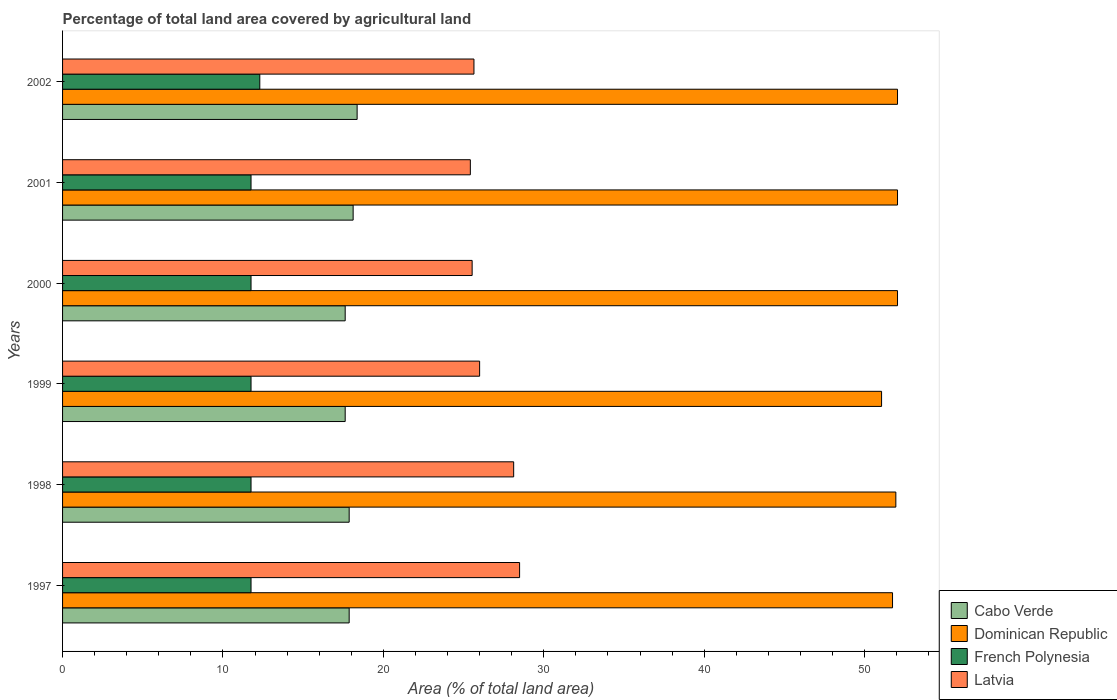Are the number of bars per tick equal to the number of legend labels?
Your response must be concise. Yes. How many bars are there on the 5th tick from the top?
Give a very brief answer. 4. What is the label of the 1st group of bars from the top?
Provide a short and direct response. 2002. What is the percentage of agricultural land in Latvia in 2001?
Offer a terse response. 25.42. Across all years, what is the maximum percentage of agricultural land in Cabo Verde?
Offer a very short reply. 18.36. Across all years, what is the minimum percentage of agricultural land in French Polynesia?
Make the answer very short. 11.75. In which year was the percentage of agricultural land in French Polynesia maximum?
Offer a very short reply. 2002. What is the total percentage of agricultural land in French Polynesia in the graph?
Make the answer very short. 71.04. What is the difference between the percentage of agricultural land in Dominican Republic in 1997 and that in 1999?
Ensure brevity in your answer.  0.68. What is the difference between the percentage of agricultural land in Latvia in 1997 and the percentage of agricultural land in Cabo Verde in 2001?
Your answer should be compact. 10.38. What is the average percentage of agricultural land in Cabo Verde per year?
Your answer should be compact. 17.91. In the year 1997, what is the difference between the percentage of agricultural land in Cabo Verde and percentage of agricultural land in French Polynesia?
Offer a very short reply. 6.12. What is the ratio of the percentage of agricultural land in Dominican Republic in 1998 to that in 2000?
Offer a terse response. 1. What is the difference between the highest and the second highest percentage of agricultural land in Latvia?
Give a very brief answer. 0.37. What is the difference between the highest and the lowest percentage of agricultural land in Latvia?
Keep it short and to the point. 3.07. In how many years, is the percentage of agricultural land in Cabo Verde greater than the average percentage of agricultural land in Cabo Verde taken over all years?
Make the answer very short. 2. Is it the case that in every year, the sum of the percentage of agricultural land in Cabo Verde and percentage of agricultural land in French Polynesia is greater than the sum of percentage of agricultural land in Latvia and percentage of agricultural land in Dominican Republic?
Ensure brevity in your answer.  Yes. What does the 4th bar from the top in 1997 represents?
Offer a terse response. Cabo Verde. What does the 1st bar from the bottom in 1998 represents?
Your answer should be very brief. Cabo Verde. Is it the case that in every year, the sum of the percentage of agricultural land in Latvia and percentage of agricultural land in Cabo Verde is greater than the percentage of agricultural land in French Polynesia?
Your answer should be compact. Yes. Are all the bars in the graph horizontal?
Give a very brief answer. Yes. How many years are there in the graph?
Make the answer very short. 6. What is the difference between two consecutive major ticks on the X-axis?
Offer a terse response. 10. Are the values on the major ticks of X-axis written in scientific E-notation?
Provide a succinct answer. No. Does the graph contain grids?
Your response must be concise. No. How are the legend labels stacked?
Ensure brevity in your answer.  Vertical. What is the title of the graph?
Offer a terse response. Percentage of total land area covered by agricultural land. What is the label or title of the X-axis?
Your response must be concise. Area (% of total land area). What is the label or title of the Y-axis?
Make the answer very short. Years. What is the Area (% of total land area) in Cabo Verde in 1997?
Offer a terse response. 17.87. What is the Area (% of total land area) of Dominican Republic in 1997?
Your response must be concise. 51.74. What is the Area (% of total land area) of French Polynesia in 1997?
Keep it short and to the point. 11.75. What is the Area (% of total land area) in Latvia in 1997?
Offer a very short reply. 28.49. What is the Area (% of total land area) of Cabo Verde in 1998?
Your answer should be very brief. 17.87. What is the Area (% of total land area) in Dominican Republic in 1998?
Your answer should be very brief. 51.95. What is the Area (% of total land area) of French Polynesia in 1998?
Provide a succinct answer. 11.75. What is the Area (% of total land area) in Latvia in 1998?
Your answer should be compact. 28.12. What is the Area (% of total land area) in Cabo Verde in 1999?
Your answer should be very brief. 17.62. What is the Area (% of total land area) of Dominican Republic in 1999?
Ensure brevity in your answer.  51.06. What is the Area (% of total land area) in French Polynesia in 1999?
Your answer should be very brief. 11.75. What is the Area (% of total land area) in Latvia in 1999?
Offer a very short reply. 26. What is the Area (% of total land area) in Cabo Verde in 2000?
Offer a terse response. 17.62. What is the Area (% of total land area) of Dominican Republic in 2000?
Provide a short and direct response. 52.05. What is the Area (% of total land area) in French Polynesia in 2000?
Ensure brevity in your answer.  11.75. What is the Area (% of total land area) of Latvia in 2000?
Provide a short and direct response. 25.53. What is the Area (% of total land area) of Cabo Verde in 2001?
Your answer should be very brief. 18.11. What is the Area (% of total land area) in Dominican Republic in 2001?
Your answer should be compact. 52.05. What is the Area (% of total land area) in French Polynesia in 2001?
Your response must be concise. 11.75. What is the Area (% of total land area) of Latvia in 2001?
Keep it short and to the point. 25.42. What is the Area (% of total land area) of Cabo Verde in 2002?
Ensure brevity in your answer.  18.36. What is the Area (% of total land area) of Dominican Republic in 2002?
Your response must be concise. 52.05. What is the Area (% of total land area) of French Polynesia in 2002?
Your response must be concise. 12.3. What is the Area (% of total land area) of Latvia in 2002?
Provide a short and direct response. 25.64. Across all years, what is the maximum Area (% of total land area) of Cabo Verde?
Provide a succinct answer. 18.36. Across all years, what is the maximum Area (% of total land area) of Dominican Republic?
Provide a succinct answer. 52.05. Across all years, what is the maximum Area (% of total land area) of French Polynesia?
Keep it short and to the point. 12.3. Across all years, what is the maximum Area (% of total land area) in Latvia?
Keep it short and to the point. 28.49. Across all years, what is the minimum Area (% of total land area) in Cabo Verde?
Your response must be concise. 17.62. Across all years, what is the minimum Area (% of total land area) of Dominican Republic?
Provide a short and direct response. 51.06. Across all years, what is the minimum Area (% of total land area) in French Polynesia?
Give a very brief answer. 11.75. Across all years, what is the minimum Area (% of total land area) of Latvia?
Ensure brevity in your answer.  25.42. What is the total Area (% of total land area) in Cabo Verde in the graph?
Offer a very short reply. 107.44. What is the total Area (% of total land area) of Dominican Republic in the graph?
Offer a terse response. 310.89. What is the total Area (% of total land area) in French Polynesia in the graph?
Give a very brief answer. 71.04. What is the total Area (% of total land area) of Latvia in the graph?
Make the answer very short. 159.21. What is the difference between the Area (% of total land area) of Dominican Republic in 1997 and that in 1998?
Keep it short and to the point. -0.21. What is the difference between the Area (% of total land area) of French Polynesia in 1997 and that in 1998?
Give a very brief answer. 0. What is the difference between the Area (% of total land area) of Latvia in 1997 and that in 1998?
Your answer should be very brief. 0.37. What is the difference between the Area (% of total land area) of Cabo Verde in 1997 and that in 1999?
Ensure brevity in your answer.  0.25. What is the difference between the Area (% of total land area) of Dominican Republic in 1997 and that in 1999?
Provide a short and direct response. 0.68. What is the difference between the Area (% of total land area) of French Polynesia in 1997 and that in 1999?
Your response must be concise. 0. What is the difference between the Area (% of total land area) in Latvia in 1997 and that in 1999?
Your answer should be very brief. 2.49. What is the difference between the Area (% of total land area) of Cabo Verde in 1997 and that in 2000?
Provide a succinct answer. 0.25. What is the difference between the Area (% of total land area) of Dominican Republic in 1997 and that in 2000?
Ensure brevity in your answer.  -0.31. What is the difference between the Area (% of total land area) of French Polynesia in 1997 and that in 2000?
Your response must be concise. 0. What is the difference between the Area (% of total land area) of Latvia in 1997 and that in 2000?
Make the answer very short. 2.96. What is the difference between the Area (% of total land area) of Cabo Verde in 1997 and that in 2001?
Offer a terse response. -0.25. What is the difference between the Area (% of total land area) of Dominican Republic in 1997 and that in 2001?
Your answer should be very brief. -0.31. What is the difference between the Area (% of total land area) in Latvia in 1997 and that in 2001?
Keep it short and to the point. 3.07. What is the difference between the Area (% of total land area) of Cabo Verde in 1997 and that in 2002?
Provide a succinct answer. -0.5. What is the difference between the Area (% of total land area) of Dominican Republic in 1997 and that in 2002?
Make the answer very short. -0.31. What is the difference between the Area (% of total land area) in French Polynesia in 1997 and that in 2002?
Make the answer very short. -0.55. What is the difference between the Area (% of total land area) of Latvia in 1997 and that in 2002?
Provide a short and direct response. 2.85. What is the difference between the Area (% of total land area) in Cabo Verde in 1998 and that in 1999?
Provide a short and direct response. 0.25. What is the difference between the Area (% of total land area) of Dominican Republic in 1998 and that in 1999?
Your answer should be very brief. 0.89. What is the difference between the Area (% of total land area) of Latvia in 1998 and that in 1999?
Keep it short and to the point. 2.12. What is the difference between the Area (% of total land area) of Cabo Verde in 1998 and that in 2000?
Provide a succinct answer. 0.25. What is the difference between the Area (% of total land area) in Dominican Republic in 1998 and that in 2000?
Ensure brevity in your answer.  -0.1. What is the difference between the Area (% of total land area) of Latvia in 1998 and that in 2000?
Offer a terse response. 2.59. What is the difference between the Area (% of total land area) of Cabo Verde in 1998 and that in 2001?
Provide a succinct answer. -0.25. What is the difference between the Area (% of total land area) in Dominican Republic in 1998 and that in 2001?
Make the answer very short. -0.1. What is the difference between the Area (% of total land area) in Latvia in 1998 and that in 2001?
Keep it short and to the point. 2.7. What is the difference between the Area (% of total land area) of Cabo Verde in 1998 and that in 2002?
Give a very brief answer. -0.5. What is the difference between the Area (% of total land area) in Dominican Republic in 1998 and that in 2002?
Make the answer very short. -0.1. What is the difference between the Area (% of total land area) of French Polynesia in 1998 and that in 2002?
Offer a terse response. -0.55. What is the difference between the Area (% of total land area) of Latvia in 1998 and that in 2002?
Provide a succinct answer. 2.48. What is the difference between the Area (% of total land area) of Cabo Verde in 1999 and that in 2000?
Provide a short and direct response. 0. What is the difference between the Area (% of total land area) in Dominican Republic in 1999 and that in 2000?
Your answer should be compact. -0.99. What is the difference between the Area (% of total land area) of Latvia in 1999 and that in 2000?
Give a very brief answer. 0.47. What is the difference between the Area (% of total land area) in Cabo Verde in 1999 and that in 2001?
Keep it short and to the point. -0.5. What is the difference between the Area (% of total land area) in Dominican Republic in 1999 and that in 2001?
Ensure brevity in your answer.  -0.99. What is the difference between the Area (% of total land area) in French Polynesia in 1999 and that in 2001?
Make the answer very short. 0. What is the difference between the Area (% of total land area) of Latvia in 1999 and that in 2001?
Your answer should be compact. 0.58. What is the difference between the Area (% of total land area) in Cabo Verde in 1999 and that in 2002?
Keep it short and to the point. -0.74. What is the difference between the Area (% of total land area) in Dominican Republic in 1999 and that in 2002?
Your answer should be very brief. -0.99. What is the difference between the Area (% of total land area) of French Polynesia in 1999 and that in 2002?
Provide a short and direct response. -0.55. What is the difference between the Area (% of total land area) of Latvia in 1999 and that in 2002?
Offer a terse response. 0.35. What is the difference between the Area (% of total land area) in Cabo Verde in 2000 and that in 2001?
Your answer should be very brief. -0.5. What is the difference between the Area (% of total land area) in Dominican Republic in 2000 and that in 2001?
Your answer should be very brief. 0. What is the difference between the Area (% of total land area) in French Polynesia in 2000 and that in 2001?
Offer a terse response. 0. What is the difference between the Area (% of total land area) of Latvia in 2000 and that in 2001?
Your answer should be very brief. 0.11. What is the difference between the Area (% of total land area) of Cabo Verde in 2000 and that in 2002?
Make the answer very short. -0.74. What is the difference between the Area (% of total land area) of French Polynesia in 2000 and that in 2002?
Keep it short and to the point. -0.55. What is the difference between the Area (% of total land area) of Latvia in 2000 and that in 2002?
Your response must be concise. -0.11. What is the difference between the Area (% of total land area) in Cabo Verde in 2001 and that in 2002?
Offer a terse response. -0.25. What is the difference between the Area (% of total land area) in French Polynesia in 2001 and that in 2002?
Offer a very short reply. -0.55. What is the difference between the Area (% of total land area) in Latvia in 2001 and that in 2002?
Provide a short and direct response. -0.23. What is the difference between the Area (% of total land area) in Cabo Verde in 1997 and the Area (% of total land area) in Dominican Republic in 1998?
Your answer should be very brief. -34.08. What is the difference between the Area (% of total land area) of Cabo Verde in 1997 and the Area (% of total land area) of French Polynesia in 1998?
Offer a very short reply. 6.12. What is the difference between the Area (% of total land area) of Cabo Verde in 1997 and the Area (% of total land area) of Latvia in 1998?
Offer a terse response. -10.25. What is the difference between the Area (% of total land area) in Dominican Republic in 1997 and the Area (% of total land area) in French Polynesia in 1998?
Offer a terse response. 39.99. What is the difference between the Area (% of total land area) in Dominican Republic in 1997 and the Area (% of total land area) in Latvia in 1998?
Make the answer very short. 23.62. What is the difference between the Area (% of total land area) in French Polynesia in 1997 and the Area (% of total land area) in Latvia in 1998?
Offer a terse response. -16.37. What is the difference between the Area (% of total land area) in Cabo Verde in 1997 and the Area (% of total land area) in Dominican Republic in 1999?
Make the answer very short. -33.19. What is the difference between the Area (% of total land area) of Cabo Verde in 1997 and the Area (% of total land area) of French Polynesia in 1999?
Your response must be concise. 6.12. What is the difference between the Area (% of total land area) in Cabo Verde in 1997 and the Area (% of total land area) in Latvia in 1999?
Offer a very short reply. -8.13. What is the difference between the Area (% of total land area) of Dominican Republic in 1997 and the Area (% of total land area) of French Polynesia in 1999?
Your answer should be compact. 39.99. What is the difference between the Area (% of total land area) in Dominican Republic in 1997 and the Area (% of total land area) in Latvia in 1999?
Provide a succinct answer. 25.74. What is the difference between the Area (% of total land area) in French Polynesia in 1997 and the Area (% of total land area) in Latvia in 1999?
Your answer should be compact. -14.25. What is the difference between the Area (% of total land area) in Cabo Verde in 1997 and the Area (% of total land area) in Dominican Republic in 2000?
Make the answer very short. -34.18. What is the difference between the Area (% of total land area) in Cabo Verde in 1997 and the Area (% of total land area) in French Polynesia in 2000?
Offer a terse response. 6.12. What is the difference between the Area (% of total land area) of Cabo Verde in 1997 and the Area (% of total land area) of Latvia in 2000?
Ensure brevity in your answer.  -7.67. What is the difference between the Area (% of total land area) in Dominican Republic in 1997 and the Area (% of total land area) in French Polynesia in 2000?
Make the answer very short. 39.99. What is the difference between the Area (% of total land area) of Dominican Republic in 1997 and the Area (% of total land area) of Latvia in 2000?
Your answer should be compact. 26.21. What is the difference between the Area (% of total land area) of French Polynesia in 1997 and the Area (% of total land area) of Latvia in 2000?
Your answer should be compact. -13.78. What is the difference between the Area (% of total land area) in Cabo Verde in 1997 and the Area (% of total land area) in Dominican Republic in 2001?
Give a very brief answer. -34.18. What is the difference between the Area (% of total land area) of Cabo Verde in 1997 and the Area (% of total land area) of French Polynesia in 2001?
Provide a short and direct response. 6.12. What is the difference between the Area (% of total land area) of Cabo Verde in 1997 and the Area (% of total land area) of Latvia in 2001?
Provide a succinct answer. -7.55. What is the difference between the Area (% of total land area) of Dominican Republic in 1997 and the Area (% of total land area) of French Polynesia in 2001?
Provide a short and direct response. 39.99. What is the difference between the Area (% of total land area) in Dominican Republic in 1997 and the Area (% of total land area) in Latvia in 2001?
Keep it short and to the point. 26.32. What is the difference between the Area (% of total land area) in French Polynesia in 1997 and the Area (% of total land area) in Latvia in 2001?
Your response must be concise. -13.67. What is the difference between the Area (% of total land area) in Cabo Verde in 1997 and the Area (% of total land area) in Dominican Republic in 2002?
Provide a short and direct response. -34.18. What is the difference between the Area (% of total land area) in Cabo Verde in 1997 and the Area (% of total land area) in French Polynesia in 2002?
Keep it short and to the point. 5.57. What is the difference between the Area (% of total land area) of Cabo Verde in 1997 and the Area (% of total land area) of Latvia in 2002?
Make the answer very short. -7.78. What is the difference between the Area (% of total land area) of Dominican Republic in 1997 and the Area (% of total land area) of French Polynesia in 2002?
Offer a very short reply. 39.44. What is the difference between the Area (% of total land area) in Dominican Republic in 1997 and the Area (% of total land area) in Latvia in 2002?
Offer a very short reply. 26.09. What is the difference between the Area (% of total land area) of French Polynesia in 1997 and the Area (% of total land area) of Latvia in 2002?
Make the answer very short. -13.9. What is the difference between the Area (% of total land area) of Cabo Verde in 1998 and the Area (% of total land area) of Dominican Republic in 1999?
Your response must be concise. -33.19. What is the difference between the Area (% of total land area) in Cabo Verde in 1998 and the Area (% of total land area) in French Polynesia in 1999?
Make the answer very short. 6.12. What is the difference between the Area (% of total land area) in Cabo Verde in 1998 and the Area (% of total land area) in Latvia in 1999?
Offer a very short reply. -8.13. What is the difference between the Area (% of total land area) of Dominican Republic in 1998 and the Area (% of total land area) of French Polynesia in 1999?
Ensure brevity in your answer.  40.2. What is the difference between the Area (% of total land area) of Dominican Republic in 1998 and the Area (% of total land area) of Latvia in 1999?
Provide a succinct answer. 25.95. What is the difference between the Area (% of total land area) of French Polynesia in 1998 and the Area (% of total land area) of Latvia in 1999?
Your answer should be compact. -14.25. What is the difference between the Area (% of total land area) of Cabo Verde in 1998 and the Area (% of total land area) of Dominican Republic in 2000?
Offer a terse response. -34.18. What is the difference between the Area (% of total land area) in Cabo Verde in 1998 and the Area (% of total land area) in French Polynesia in 2000?
Ensure brevity in your answer.  6.12. What is the difference between the Area (% of total land area) of Cabo Verde in 1998 and the Area (% of total land area) of Latvia in 2000?
Offer a very short reply. -7.67. What is the difference between the Area (% of total land area) in Dominican Republic in 1998 and the Area (% of total land area) in French Polynesia in 2000?
Ensure brevity in your answer.  40.2. What is the difference between the Area (% of total land area) of Dominican Republic in 1998 and the Area (% of total land area) of Latvia in 2000?
Ensure brevity in your answer.  26.41. What is the difference between the Area (% of total land area) in French Polynesia in 1998 and the Area (% of total land area) in Latvia in 2000?
Offer a terse response. -13.78. What is the difference between the Area (% of total land area) of Cabo Verde in 1998 and the Area (% of total land area) of Dominican Republic in 2001?
Provide a short and direct response. -34.18. What is the difference between the Area (% of total land area) of Cabo Verde in 1998 and the Area (% of total land area) of French Polynesia in 2001?
Make the answer very short. 6.12. What is the difference between the Area (% of total land area) in Cabo Verde in 1998 and the Area (% of total land area) in Latvia in 2001?
Ensure brevity in your answer.  -7.55. What is the difference between the Area (% of total land area) of Dominican Republic in 1998 and the Area (% of total land area) of French Polynesia in 2001?
Keep it short and to the point. 40.2. What is the difference between the Area (% of total land area) in Dominican Republic in 1998 and the Area (% of total land area) in Latvia in 2001?
Your answer should be compact. 26.53. What is the difference between the Area (% of total land area) of French Polynesia in 1998 and the Area (% of total land area) of Latvia in 2001?
Offer a terse response. -13.67. What is the difference between the Area (% of total land area) in Cabo Verde in 1998 and the Area (% of total land area) in Dominican Republic in 2002?
Make the answer very short. -34.18. What is the difference between the Area (% of total land area) in Cabo Verde in 1998 and the Area (% of total land area) in French Polynesia in 2002?
Your answer should be compact. 5.57. What is the difference between the Area (% of total land area) in Cabo Verde in 1998 and the Area (% of total land area) in Latvia in 2002?
Offer a terse response. -7.78. What is the difference between the Area (% of total land area) of Dominican Republic in 1998 and the Area (% of total land area) of French Polynesia in 2002?
Offer a very short reply. 39.65. What is the difference between the Area (% of total land area) of Dominican Republic in 1998 and the Area (% of total land area) of Latvia in 2002?
Make the answer very short. 26.3. What is the difference between the Area (% of total land area) in French Polynesia in 1998 and the Area (% of total land area) in Latvia in 2002?
Your response must be concise. -13.9. What is the difference between the Area (% of total land area) of Cabo Verde in 1999 and the Area (% of total land area) of Dominican Republic in 2000?
Offer a terse response. -34.43. What is the difference between the Area (% of total land area) of Cabo Verde in 1999 and the Area (% of total land area) of French Polynesia in 2000?
Ensure brevity in your answer.  5.87. What is the difference between the Area (% of total land area) of Cabo Verde in 1999 and the Area (% of total land area) of Latvia in 2000?
Provide a succinct answer. -7.91. What is the difference between the Area (% of total land area) in Dominican Republic in 1999 and the Area (% of total land area) in French Polynesia in 2000?
Give a very brief answer. 39.31. What is the difference between the Area (% of total land area) of Dominican Republic in 1999 and the Area (% of total land area) of Latvia in 2000?
Ensure brevity in your answer.  25.52. What is the difference between the Area (% of total land area) in French Polynesia in 1999 and the Area (% of total land area) in Latvia in 2000?
Your response must be concise. -13.78. What is the difference between the Area (% of total land area) of Cabo Verde in 1999 and the Area (% of total land area) of Dominican Republic in 2001?
Ensure brevity in your answer.  -34.43. What is the difference between the Area (% of total land area) of Cabo Verde in 1999 and the Area (% of total land area) of French Polynesia in 2001?
Make the answer very short. 5.87. What is the difference between the Area (% of total land area) of Cabo Verde in 1999 and the Area (% of total land area) of Latvia in 2001?
Offer a very short reply. -7.8. What is the difference between the Area (% of total land area) in Dominican Republic in 1999 and the Area (% of total land area) in French Polynesia in 2001?
Your response must be concise. 39.31. What is the difference between the Area (% of total land area) in Dominican Republic in 1999 and the Area (% of total land area) in Latvia in 2001?
Offer a very short reply. 25.64. What is the difference between the Area (% of total land area) of French Polynesia in 1999 and the Area (% of total land area) of Latvia in 2001?
Provide a short and direct response. -13.67. What is the difference between the Area (% of total land area) of Cabo Verde in 1999 and the Area (% of total land area) of Dominican Republic in 2002?
Offer a very short reply. -34.43. What is the difference between the Area (% of total land area) of Cabo Verde in 1999 and the Area (% of total land area) of French Polynesia in 2002?
Your response must be concise. 5.32. What is the difference between the Area (% of total land area) of Cabo Verde in 1999 and the Area (% of total land area) of Latvia in 2002?
Your response must be concise. -8.03. What is the difference between the Area (% of total land area) of Dominican Republic in 1999 and the Area (% of total land area) of French Polynesia in 2002?
Your answer should be compact. 38.76. What is the difference between the Area (% of total land area) of Dominican Republic in 1999 and the Area (% of total land area) of Latvia in 2002?
Ensure brevity in your answer.  25.41. What is the difference between the Area (% of total land area) in French Polynesia in 1999 and the Area (% of total land area) in Latvia in 2002?
Offer a terse response. -13.9. What is the difference between the Area (% of total land area) in Cabo Verde in 2000 and the Area (% of total land area) in Dominican Republic in 2001?
Your answer should be compact. -34.43. What is the difference between the Area (% of total land area) of Cabo Verde in 2000 and the Area (% of total land area) of French Polynesia in 2001?
Ensure brevity in your answer.  5.87. What is the difference between the Area (% of total land area) in Cabo Verde in 2000 and the Area (% of total land area) in Latvia in 2001?
Keep it short and to the point. -7.8. What is the difference between the Area (% of total land area) of Dominican Republic in 2000 and the Area (% of total land area) of French Polynesia in 2001?
Give a very brief answer. 40.3. What is the difference between the Area (% of total land area) of Dominican Republic in 2000 and the Area (% of total land area) of Latvia in 2001?
Give a very brief answer. 26.63. What is the difference between the Area (% of total land area) of French Polynesia in 2000 and the Area (% of total land area) of Latvia in 2001?
Offer a very short reply. -13.67. What is the difference between the Area (% of total land area) in Cabo Verde in 2000 and the Area (% of total land area) in Dominican Republic in 2002?
Give a very brief answer. -34.43. What is the difference between the Area (% of total land area) of Cabo Verde in 2000 and the Area (% of total land area) of French Polynesia in 2002?
Ensure brevity in your answer.  5.32. What is the difference between the Area (% of total land area) in Cabo Verde in 2000 and the Area (% of total land area) in Latvia in 2002?
Give a very brief answer. -8.03. What is the difference between the Area (% of total land area) of Dominican Republic in 2000 and the Area (% of total land area) of French Polynesia in 2002?
Make the answer very short. 39.75. What is the difference between the Area (% of total land area) in Dominican Republic in 2000 and the Area (% of total land area) in Latvia in 2002?
Your answer should be very brief. 26.4. What is the difference between the Area (% of total land area) of French Polynesia in 2000 and the Area (% of total land area) of Latvia in 2002?
Your response must be concise. -13.9. What is the difference between the Area (% of total land area) of Cabo Verde in 2001 and the Area (% of total land area) of Dominican Republic in 2002?
Your response must be concise. -33.93. What is the difference between the Area (% of total land area) of Cabo Verde in 2001 and the Area (% of total land area) of French Polynesia in 2002?
Ensure brevity in your answer.  5.82. What is the difference between the Area (% of total land area) in Cabo Verde in 2001 and the Area (% of total land area) in Latvia in 2002?
Your response must be concise. -7.53. What is the difference between the Area (% of total land area) of Dominican Republic in 2001 and the Area (% of total land area) of French Polynesia in 2002?
Ensure brevity in your answer.  39.75. What is the difference between the Area (% of total land area) in Dominican Republic in 2001 and the Area (% of total land area) in Latvia in 2002?
Keep it short and to the point. 26.4. What is the difference between the Area (% of total land area) of French Polynesia in 2001 and the Area (% of total land area) of Latvia in 2002?
Your answer should be very brief. -13.9. What is the average Area (% of total land area) in Cabo Verde per year?
Make the answer very short. 17.91. What is the average Area (% of total land area) in Dominican Republic per year?
Provide a succinct answer. 51.81. What is the average Area (% of total land area) in French Polynesia per year?
Provide a short and direct response. 11.84. What is the average Area (% of total land area) of Latvia per year?
Your answer should be compact. 26.53. In the year 1997, what is the difference between the Area (% of total land area) of Cabo Verde and Area (% of total land area) of Dominican Republic?
Your answer should be compact. -33.87. In the year 1997, what is the difference between the Area (% of total land area) of Cabo Verde and Area (% of total land area) of French Polynesia?
Your answer should be compact. 6.12. In the year 1997, what is the difference between the Area (% of total land area) of Cabo Verde and Area (% of total land area) of Latvia?
Make the answer very short. -10.62. In the year 1997, what is the difference between the Area (% of total land area) in Dominican Republic and Area (% of total land area) in French Polynesia?
Your answer should be compact. 39.99. In the year 1997, what is the difference between the Area (% of total land area) of Dominican Republic and Area (% of total land area) of Latvia?
Your answer should be very brief. 23.25. In the year 1997, what is the difference between the Area (% of total land area) in French Polynesia and Area (% of total land area) in Latvia?
Your response must be concise. -16.74. In the year 1998, what is the difference between the Area (% of total land area) of Cabo Verde and Area (% of total land area) of Dominican Republic?
Provide a short and direct response. -34.08. In the year 1998, what is the difference between the Area (% of total land area) of Cabo Verde and Area (% of total land area) of French Polynesia?
Your answer should be compact. 6.12. In the year 1998, what is the difference between the Area (% of total land area) of Cabo Verde and Area (% of total land area) of Latvia?
Your answer should be very brief. -10.25. In the year 1998, what is the difference between the Area (% of total land area) in Dominican Republic and Area (% of total land area) in French Polynesia?
Your response must be concise. 40.2. In the year 1998, what is the difference between the Area (% of total land area) in Dominican Republic and Area (% of total land area) in Latvia?
Your response must be concise. 23.82. In the year 1998, what is the difference between the Area (% of total land area) in French Polynesia and Area (% of total land area) in Latvia?
Offer a terse response. -16.37. In the year 1999, what is the difference between the Area (% of total land area) of Cabo Verde and Area (% of total land area) of Dominican Republic?
Ensure brevity in your answer.  -33.44. In the year 1999, what is the difference between the Area (% of total land area) of Cabo Verde and Area (% of total land area) of French Polynesia?
Provide a short and direct response. 5.87. In the year 1999, what is the difference between the Area (% of total land area) of Cabo Verde and Area (% of total land area) of Latvia?
Your response must be concise. -8.38. In the year 1999, what is the difference between the Area (% of total land area) of Dominican Republic and Area (% of total land area) of French Polynesia?
Provide a succinct answer. 39.31. In the year 1999, what is the difference between the Area (% of total land area) in Dominican Republic and Area (% of total land area) in Latvia?
Give a very brief answer. 25.06. In the year 1999, what is the difference between the Area (% of total land area) in French Polynesia and Area (% of total land area) in Latvia?
Your answer should be very brief. -14.25. In the year 2000, what is the difference between the Area (% of total land area) in Cabo Verde and Area (% of total land area) in Dominican Republic?
Give a very brief answer. -34.43. In the year 2000, what is the difference between the Area (% of total land area) in Cabo Verde and Area (% of total land area) in French Polynesia?
Your response must be concise. 5.87. In the year 2000, what is the difference between the Area (% of total land area) in Cabo Verde and Area (% of total land area) in Latvia?
Offer a very short reply. -7.91. In the year 2000, what is the difference between the Area (% of total land area) of Dominican Republic and Area (% of total land area) of French Polynesia?
Your answer should be very brief. 40.3. In the year 2000, what is the difference between the Area (% of total land area) of Dominican Republic and Area (% of total land area) of Latvia?
Your answer should be compact. 26.52. In the year 2000, what is the difference between the Area (% of total land area) of French Polynesia and Area (% of total land area) of Latvia?
Offer a terse response. -13.78. In the year 2001, what is the difference between the Area (% of total land area) of Cabo Verde and Area (% of total land area) of Dominican Republic?
Your answer should be very brief. -33.93. In the year 2001, what is the difference between the Area (% of total land area) in Cabo Verde and Area (% of total land area) in French Polynesia?
Ensure brevity in your answer.  6.37. In the year 2001, what is the difference between the Area (% of total land area) in Cabo Verde and Area (% of total land area) in Latvia?
Your response must be concise. -7.31. In the year 2001, what is the difference between the Area (% of total land area) of Dominican Republic and Area (% of total land area) of French Polynesia?
Ensure brevity in your answer.  40.3. In the year 2001, what is the difference between the Area (% of total land area) in Dominican Republic and Area (% of total land area) in Latvia?
Make the answer very short. 26.63. In the year 2001, what is the difference between the Area (% of total land area) of French Polynesia and Area (% of total land area) of Latvia?
Offer a very short reply. -13.67. In the year 2002, what is the difference between the Area (% of total land area) in Cabo Verde and Area (% of total land area) in Dominican Republic?
Your answer should be compact. -33.69. In the year 2002, what is the difference between the Area (% of total land area) in Cabo Verde and Area (% of total land area) in French Polynesia?
Give a very brief answer. 6.07. In the year 2002, what is the difference between the Area (% of total land area) in Cabo Verde and Area (% of total land area) in Latvia?
Offer a terse response. -7.28. In the year 2002, what is the difference between the Area (% of total land area) of Dominican Republic and Area (% of total land area) of French Polynesia?
Provide a short and direct response. 39.75. In the year 2002, what is the difference between the Area (% of total land area) in Dominican Republic and Area (% of total land area) in Latvia?
Provide a short and direct response. 26.4. In the year 2002, what is the difference between the Area (% of total land area) in French Polynesia and Area (% of total land area) in Latvia?
Keep it short and to the point. -13.35. What is the ratio of the Area (% of total land area) in French Polynesia in 1997 to that in 1998?
Ensure brevity in your answer.  1. What is the ratio of the Area (% of total land area) of Latvia in 1997 to that in 1998?
Keep it short and to the point. 1.01. What is the ratio of the Area (% of total land area) in Cabo Verde in 1997 to that in 1999?
Your response must be concise. 1.01. What is the ratio of the Area (% of total land area) of Dominican Republic in 1997 to that in 1999?
Your answer should be compact. 1.01. What is the ratio of the Area (% of total land area) of French Polynesia in 1997 to that in 1999?
Give a very brief answer. 1. What is the ratio of the Area (% of total land area) of Latvia in 1997 to that in 1999?
Provide a short and direct response. 1.1. What is the ratio of the Area (% of total land area) in Cabo Verde in 1997 to that in 2000?
Provide a succinct answer. 1.01. What is the ratio of the Area (% of total land area) in French Polynesia in 1997 to that in 2000?
Give a very brief answer. 1. What is the ratio of the Area (% of total land area) in Latvia in 1997 to that in 2000?
Offer a terse response. 1.12. What is the ratio of the Area (% of total land area) in Cabo Verde in 1997 to that in 2001?
Offer a terse response. 0.99. What is the ratio of the Area (% of total land area) of French Polynesia in 1997 to that in 2001?
Give a very brief answer. 1. What is the ratio of the Area (% of total land area) in Latvia in 1997 to that in 2001?
Ensure brevity in your answer.  1.12. What is the ratio of the Area (% of total land area) of Dominican Republic in 1997 to that in 2002?
Keep it short and to the point. 0.99. What is the ratio of the Area (% of total land area) of French Polynesia in 1997 to that in 2002?
Your answer should be compact. 0.96. What is the ratio of the Area (% of total land area) in Latvia in 1997 to that in 2002?
Ensure brevity in your answer.  1.11. What is the ratio of the Area (% of total land area) of Cabo Verde in 1998 to that in 1999?
Offer a terse response. 1.01. What is the ratio of the Area (% of total land area) of Dominican Republic in 1998 to that in 1999?
Provide a short and direct response. 1.02. What is the ratio of the Area (% of total land area) in French Polynesia in 1998 to that in 1999?
Provide a succinct answer. 1. What is the ratio of the Area (% of total land area) of Latvia in 1998 to that in 1999?
Provide a succinct answer. 1.08. What is the ratio of the Area (% of total land area) in Cabo Verde in 1998 to that in 2000?
Make the answer very short. 1.01. What is the ratio of the Area (% of total land area) of Dominican Republic in 1998 to that in 2000?
Offer a terse response. 1. What is the ratio of the Area (% of total land area) of French Polynesia in 1998 to that in 2000?
Offer a very short reply. 1. What is the ratio of the Area (% of total land area) of Latvia in 1998 to that in 2000?
Keep it short and to the point. 1.1. What is the ratio of the Area (% of total land area) of Cabo Verde in 1998 to that in 2001?
Provide a succinct answer. 0.99. What is the ratio of the Area (% of total land area) of Latvia in 1998 to that in 2001?
Your answer should be very brief. 1.11. What is the ratio of the Area (% of total land area) of Cabo Verde in 1998 to that in 2002?
Provide a succinct answer. 0.97. What is the ratio of the Area (% of total land area) of Dominican Republic in 1998 to that in 2002?
Offer a terse response. 1. What is the ratio of the Area (% of total land area) in French Polynesia in 1998 to that in 2002?
Ensure brevity in your answer.  0.96. What is the ratio of the Area (% of total land area) in Latvia in 1998 to that in 2002?
Your answer should be compact. 1.1. What is the ratio of the Area (% of total land area) in Dominican Republic in 1999 to that in 2000?
Provide a short and direct response. 0.98. What is the ratio of the Area (% of total land area) of Latvia in 1999 to that in 2000?
Offer a very short reply. 1.02. What is the ratio of the Area (% of total land area) in Cabo Verde in 1999 to that in 2001?
Offer a terse response. 0.97. What is the ratio of the Area (% of total land area) of Dominican Republic in 1999 to that in 2001?
Offer a very short reply. 0.98. What is the ratio of the Area (% of total land area) in Latvia in 1999 to that in 2001?
Your response must be concise. 1.02. What is the ratio of the Area (% of total land area) in Cabo Verde in 1999 to that in 2002?
Give a very brief answer. 0.96. What is the ratio of the Area (% of total land area) in Dominican Republic in 1999 to that in 2002?
Make the answer very short. 0.98. What is the ratio of the Area (% of total land area) in French Polynesia in 1999 to that in 2002?
Provide a short and direct response. 0.96. What is the ratio of the Area (% of total land area) of Latvia in 1999 to that in 2002?
Your response must be concise. 1.01. What is the ratio of the Area (% of total land area) of Cabo Verde in 2000 to that in 2001?
Your answer should be compact. 0.97. What is the ratio of the Area (% of total land area) of Latvia in 2000 to that in 2001?
Offer a terse response. 1. What is the ratio of the Area (% of total land area) of Cabo Verde in 2000 to that in 2002?
Offer a terse response. 0.96. What is the ratio of the Area (% of total land area) in Dominican Republic in 2000 to that in 2002?
Ensure brevity in your answer.  1. What is the ratio of the Area (% of total land area) in French Polynesia in 2000 to that in 2002?
Offer a very short reply. 0.96. What is the ratio of the Area (% of total land area) of Cabo Verde in 2001 to that in 2002?
Your answer should be very brief. 0.99. What is the ratio of the Area (% of total land area) in Dominican Republic in 2001 to that in 2002?
Provide a succinct answer. 1. What is the ratio of the Area (% of total land area) in French Polynesia in 2001 to that in 2002?
Your answer should be very brief. 0.96. What is the ratio of the Area (% of total land area) of Latvia in 2001 to that in 2002?
Your answer should be compact. 0.99. What is the difference between the highest and the second highest Area (% of total land area) of Cabo Verde?
Offer a very short reply. 0.25. What is the difference between the highest and the second highest Area (% of total land area) of French Polynesia?
Ensure brevity in your answer.  0.55. What is the difference between the highest and the second highest Area (% of total land area) in Latvia?
Ensure brevity in your answer.  0.37. What is the difference between the highest and the lowest Area (% of total land area) in Cabo Verde?
Your answer should be very brief. 0.74. What is the difference between the highest and the lowest Area (% of total land area) of Dominican Republic?
Give a very brief answer. 0.99. What is the difference between the highest and the lowest Area (% of total land area) of French Polynesia?
Make the answer very short. 0.55. What is the difference between the highest and the lowest Area (% of total land area) of Latvia?
Give a very brief answer. 3.07. 